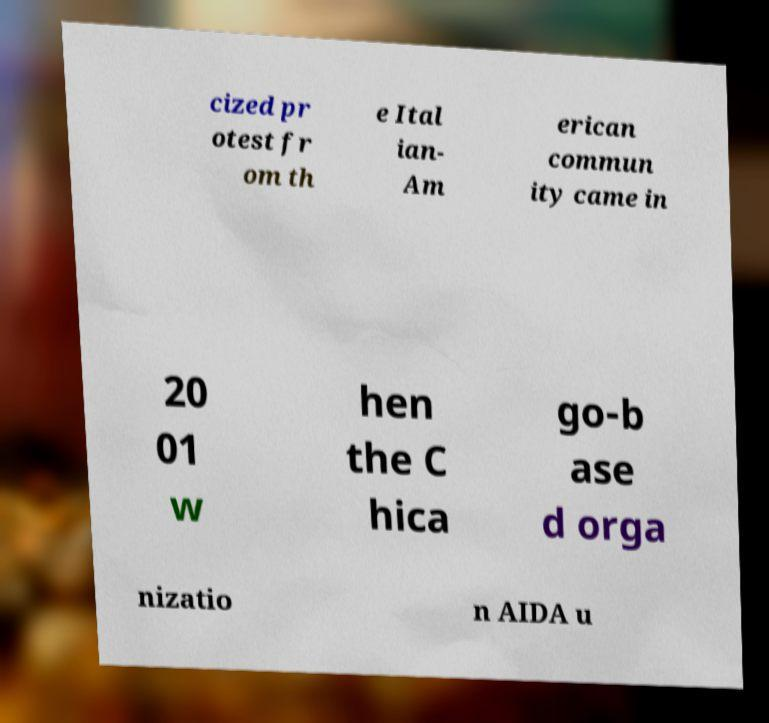I need the written content from this picture converted into text. Can you do that? cized pr otest fr om th e Ital ian- Am erican commun ity came in 20 01 w hen the C hica go-b ase d orga nizatio n AIDA u 